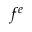Convert formula to latex. <formula><loc_0><loc_0><loc_500><loc_500>f ^ { e }</formula> 